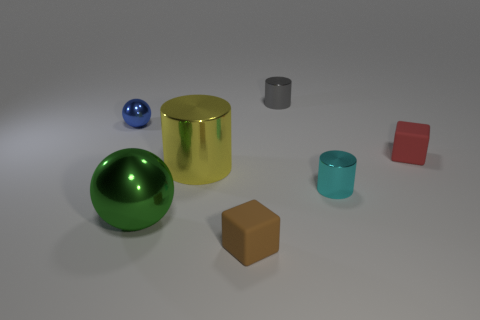Are there an equal number of big green balls right of the small red rubber thing and small shiny spheres that are to the right of the large green metal object?
Provide a succinct answer. Yes. Do the cyan thing that is behind the large metal sphere and the green sphere that is on the left side of the small gray metal thing have the same material?
Provide a short and direct response. Yes. What number of other things are the same size as the gray metal cylinder?
Your answer should be compact. 4. How many objects are tiny blue objects or metallic balls that are behind the tiny cyan thing?
Your answer should be very brief. 1. Is the number of yellow cylinders that are on the right side of the red cube the same as the number of small rubber cylinders?
Make the answer very short. Yes. There is a yellow object that is the same material as the green object; what shape is it?
Provide a short and direct response. Cylinder. Are there any metal objects of the same color as the large cylinder?
Keep it short and to the point. No. What number of rubber things are either tiny gray cylinders or tiny spheres?
Provide a succinct answer. 0. There is a rubber object that is behind the small brown thing; how many cyan metal things are behind it?
Make the answer very short. 0. What number of small red cubes are the same material as the brown cube?
Keep it short and to the point. 1. 